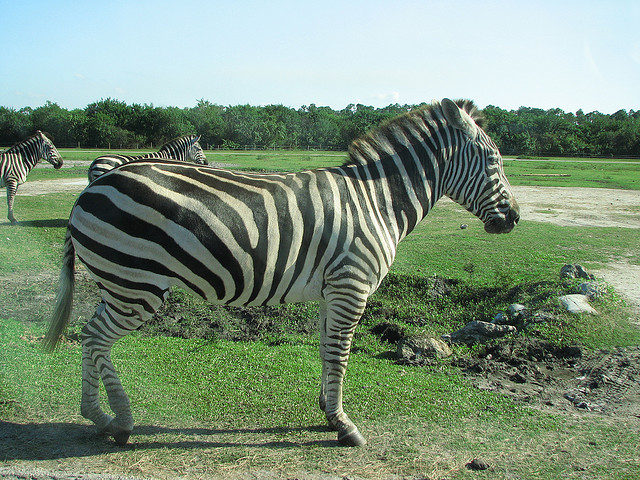<image>What landforms are in the background of this picture? It is not certain what landforms are in the background of this picture. It may be a forest or perhaps just trees. What animal is laying on the ground? There is no animal laying on the ground in the image. What animal is laying on the ground? There is no animal laying on the ground. What landforms are in the background of this picture? I don't know what landforms are in the background of this picture. It can be seen trees, forest, plain, woods or flatlands. 